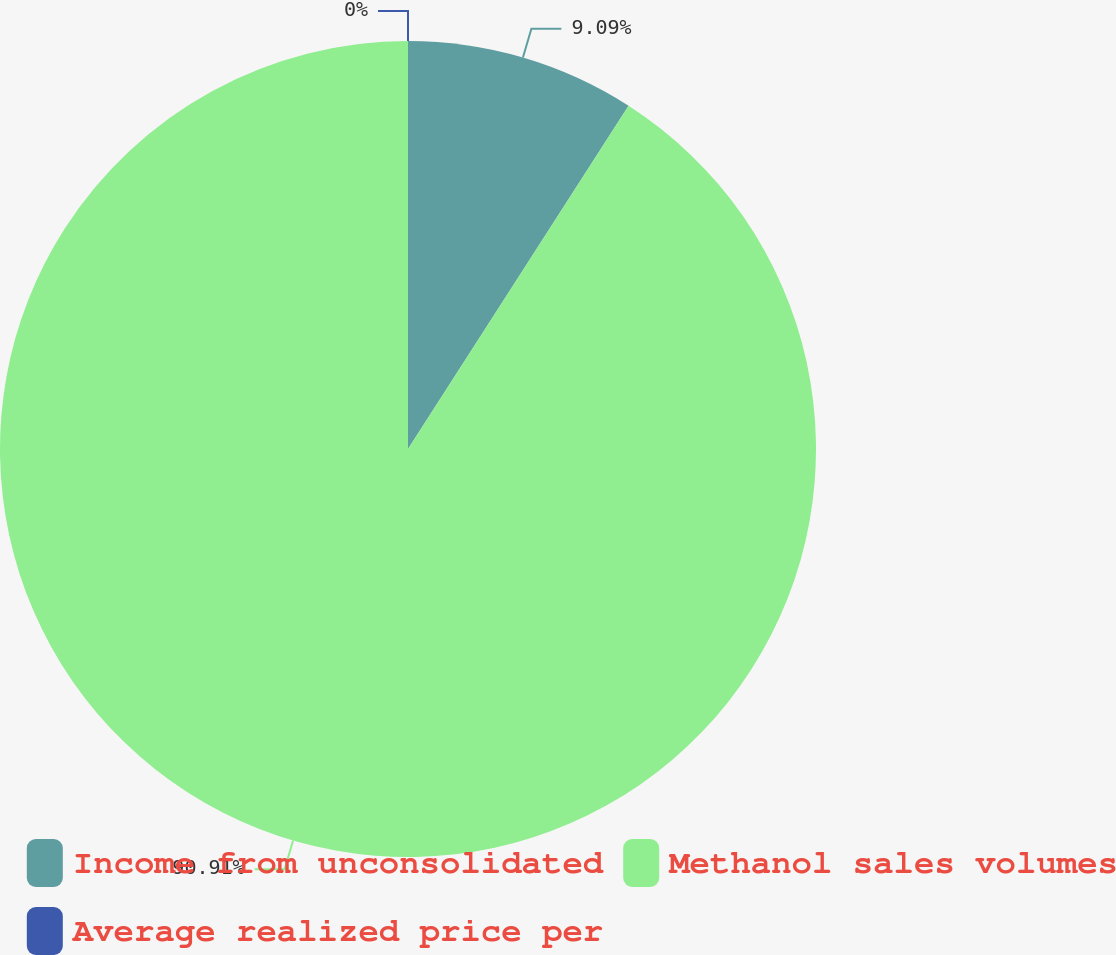<chart> <loc_0><loc_0><loc_500><loc_500><pie_chart><fcel>Income from unconsolidated<fcel>Methanol sales volumes<fcel>Average realized price per<nl><fcel>9.09%<fcel>90.91%<fcel>0.0%<nl></chart> 